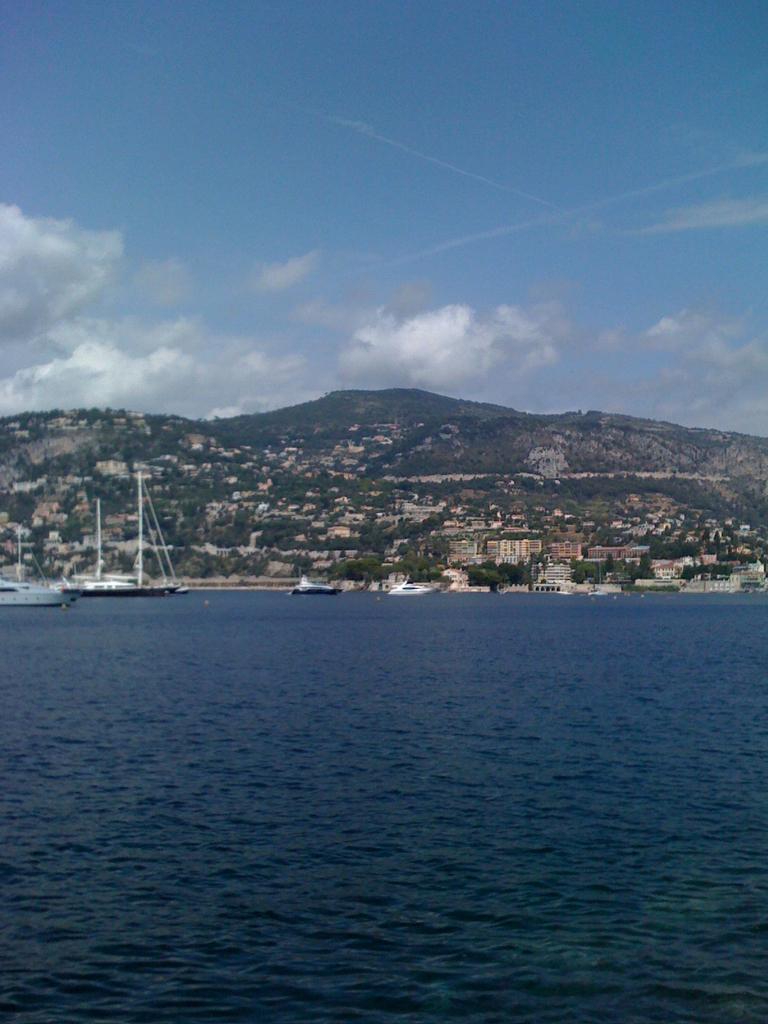Can you describe this image briefly? In this image we can see some ships, buildings, trees, mountains and other objects. At the top of the image there is the sky. At the bottom of the image there is water. 